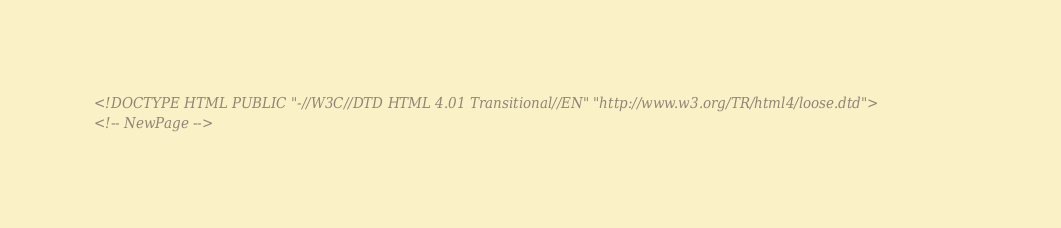<code> <loc_0><loc_0><loc_500><loc_500><_HTML_><!DOCTYPE HTML PUBLIC "-//W3C//DTD HTML 4.01 Transitional//EN" "http://www.w3.org/TR/html4/loose.dtd">
<!-- NewPage --></code> 